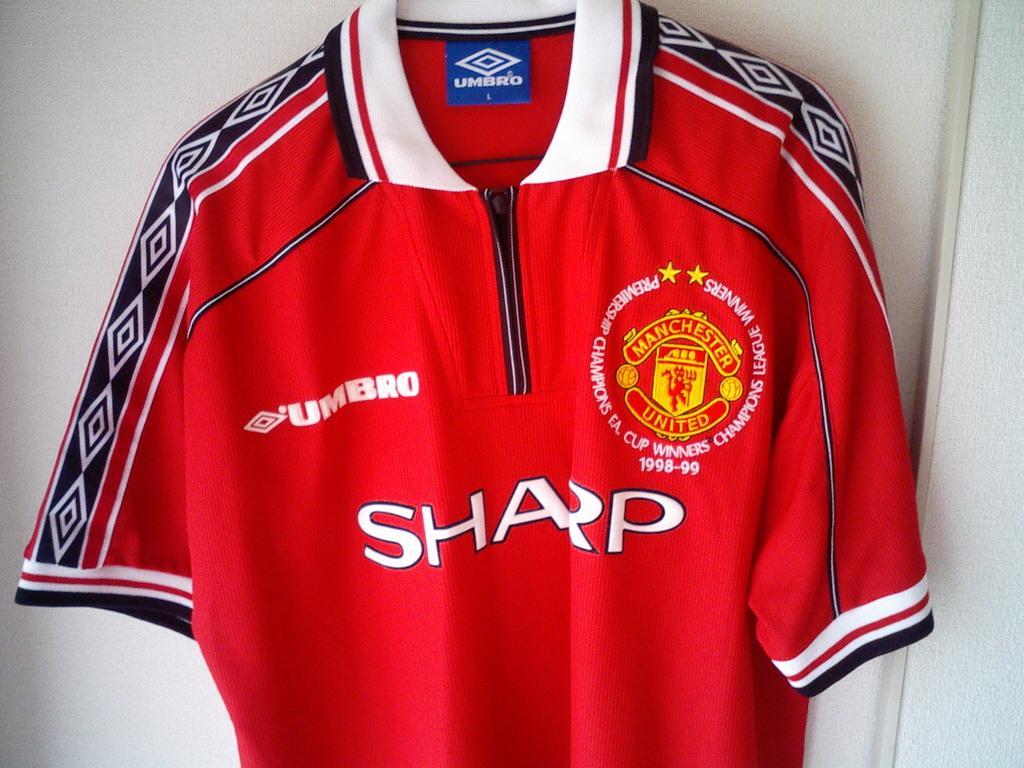Please provide a concise description of this image. In this picture I can see a red t shirt with logos on it, and in the background there is a wall. 